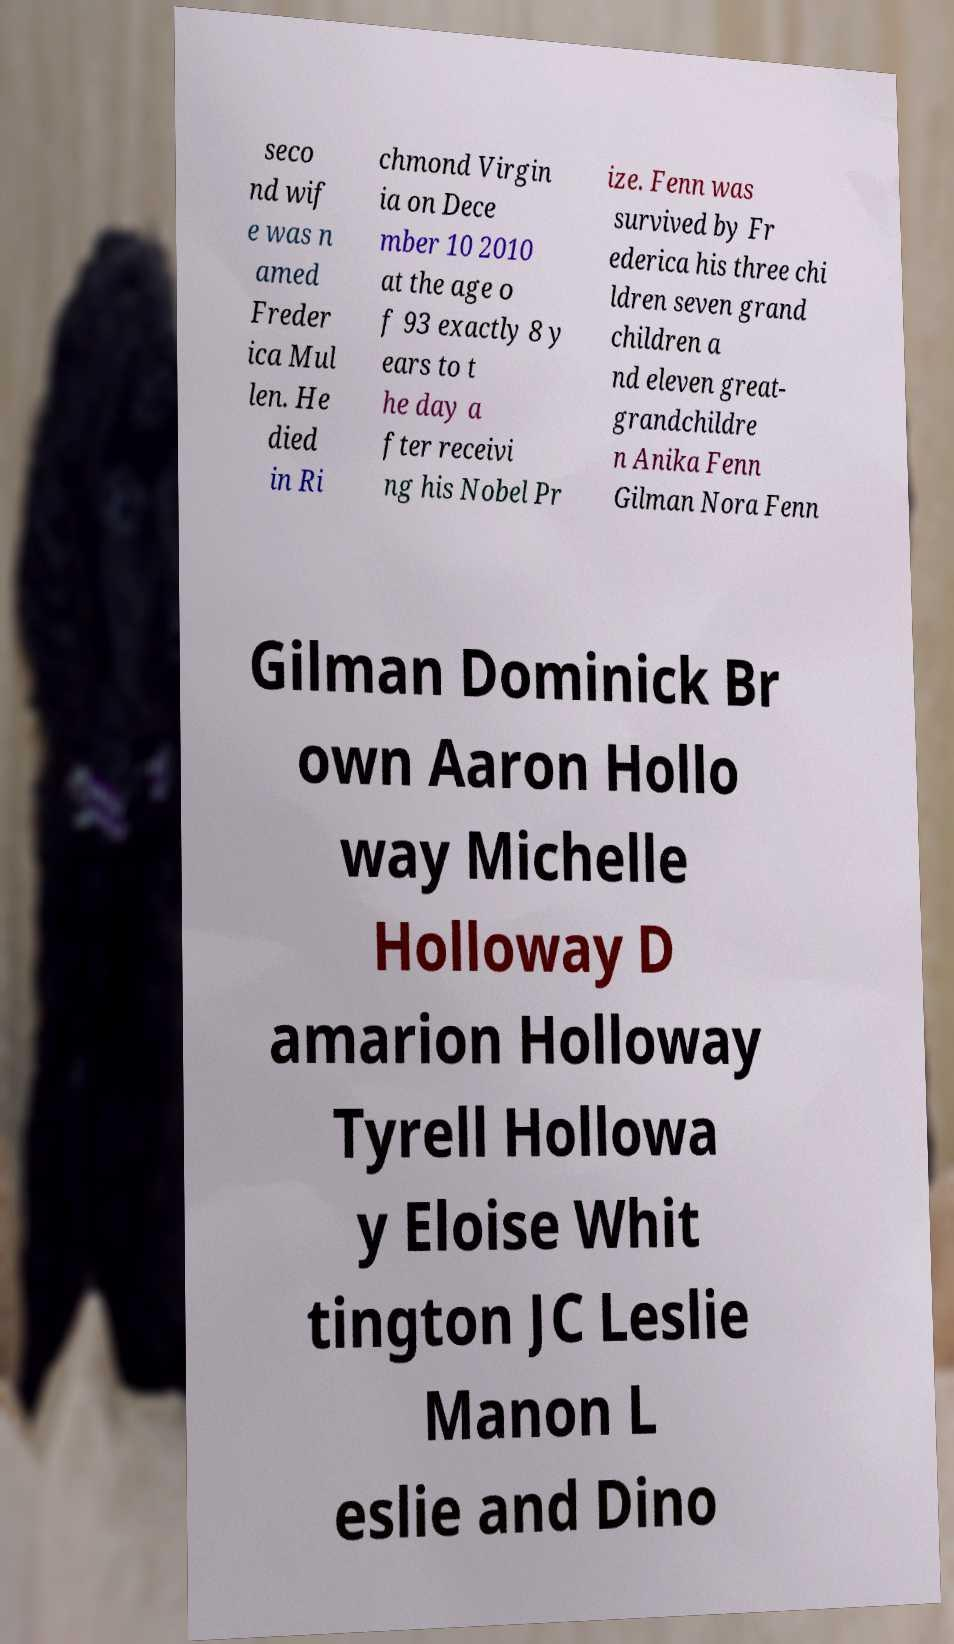Could you extract and type out the text from this image? seco nd wif e was n amed Freder ica Mul len. He died in Ri chmond Virgin ia on Dece mber 10 2010 at the age o f 93 exactly 8 y ears to t he day a fter receivi ng his Nobel Pr ize. Fenn was survived by Fr ederica his three chi ldren seven grand children a nd eleven great- grandchildre n Anika Fenn Gilman Nora Fenn Gilman Dominick Br own Aaron Hollo way Michelle Holloway D amarion Holloway Tyrell Hollowa y Eloise Whit tington JC Leslie Manon L eslie and Dino 